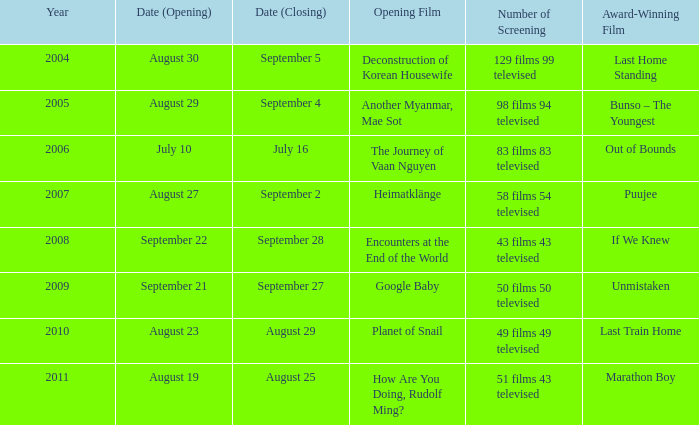How many award-winning films have the opening film of encounters at the end of the world? 1.0. 